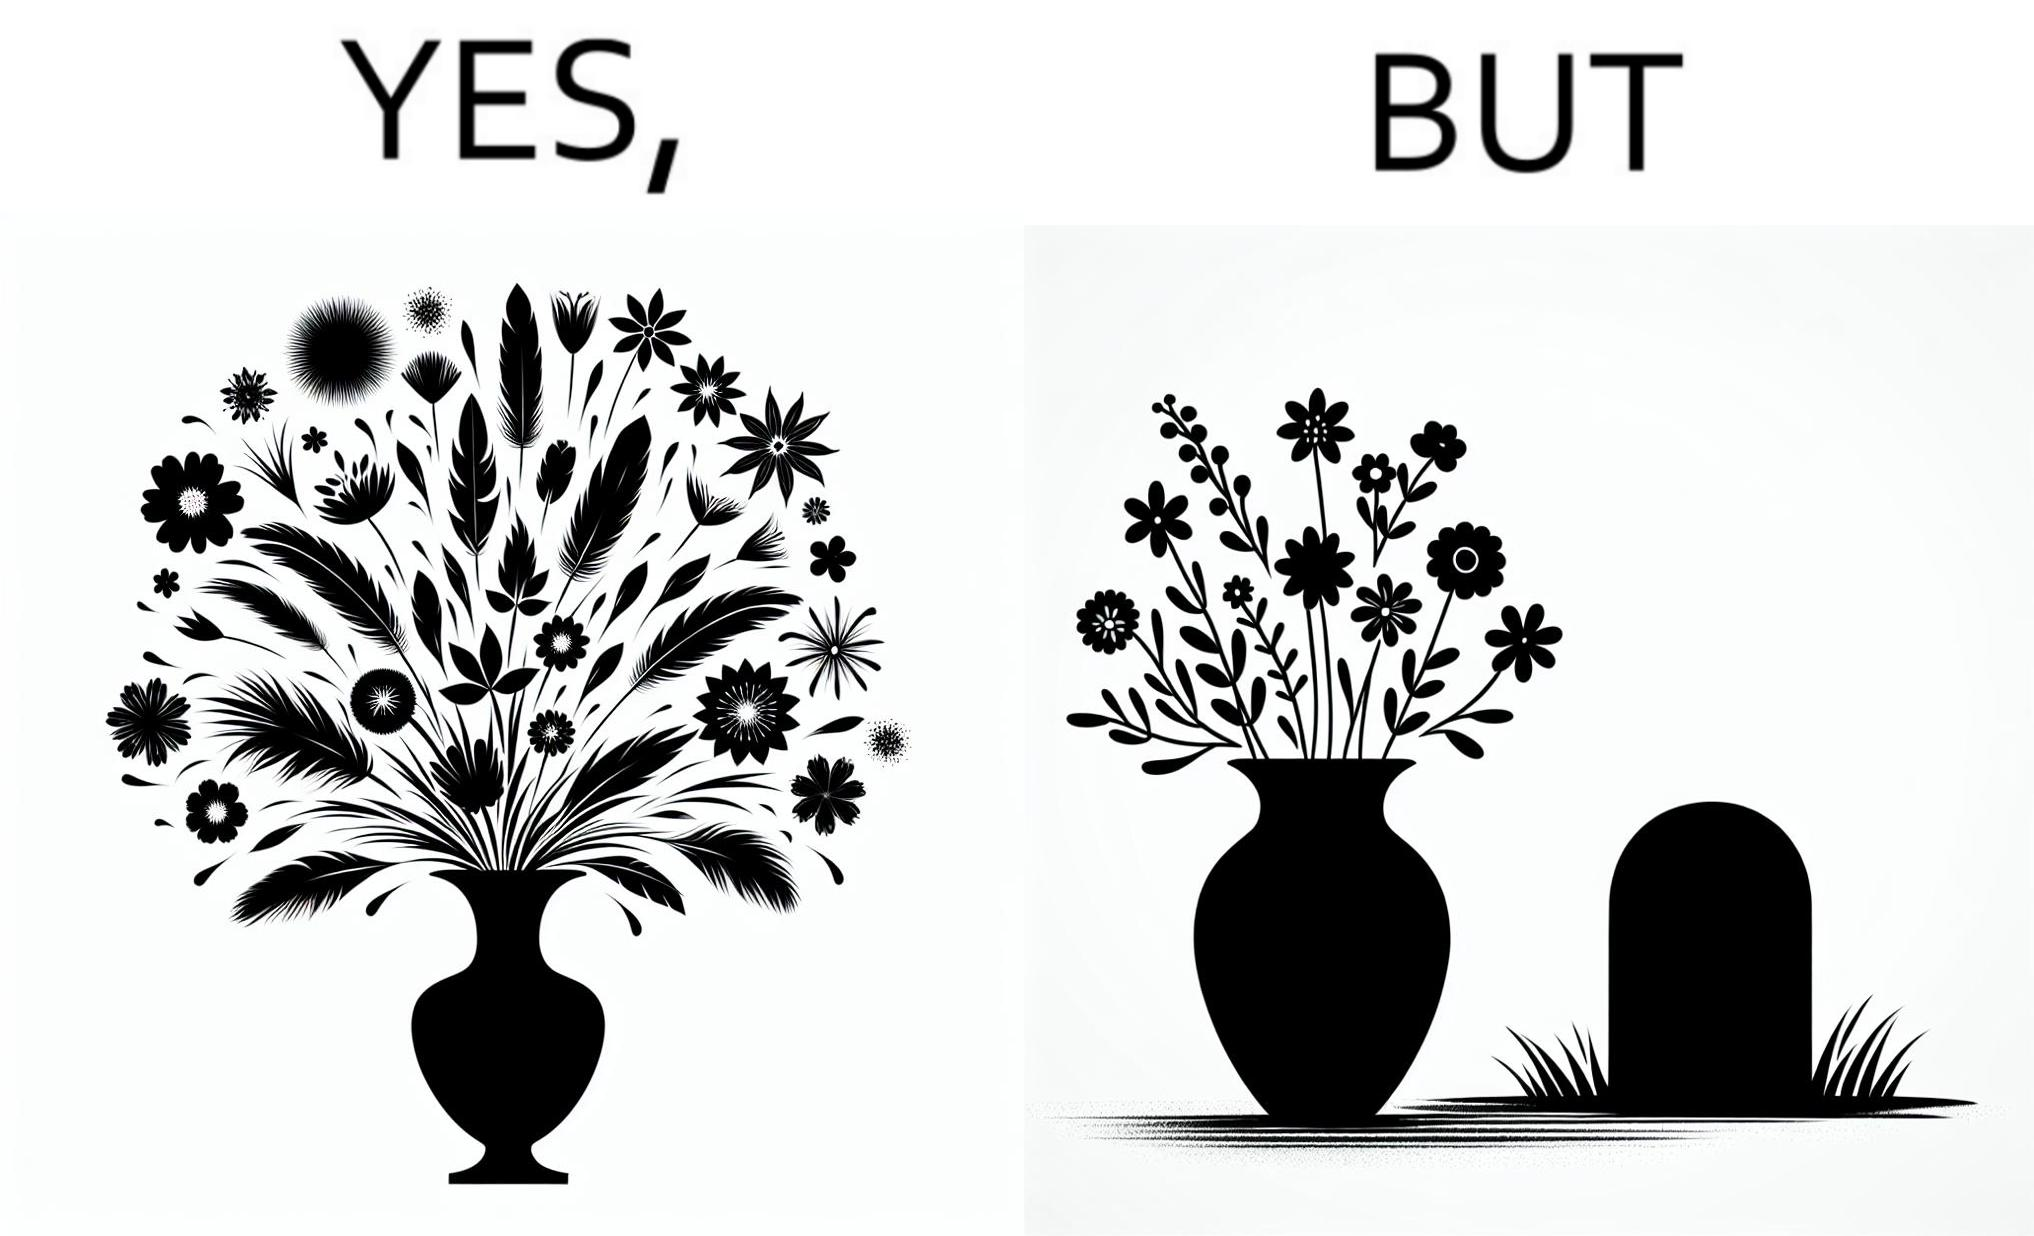Provide a description of this image. The image is ironic, because in the first image a vase full of different beautiful flowers is seen which spreads a feeling of positivity, cheerfulness etc., whereas in the second image when the same vase is put in front of a grave stone it produces a feeling of sorrow 